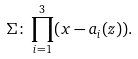<formula> <loc_0><loc_0><loc_500><loc_500>\Sigma \colon \prod _ { i = 1 } ^ { 3 } ( x - a _ { i } ( z ) ) .</formula> 